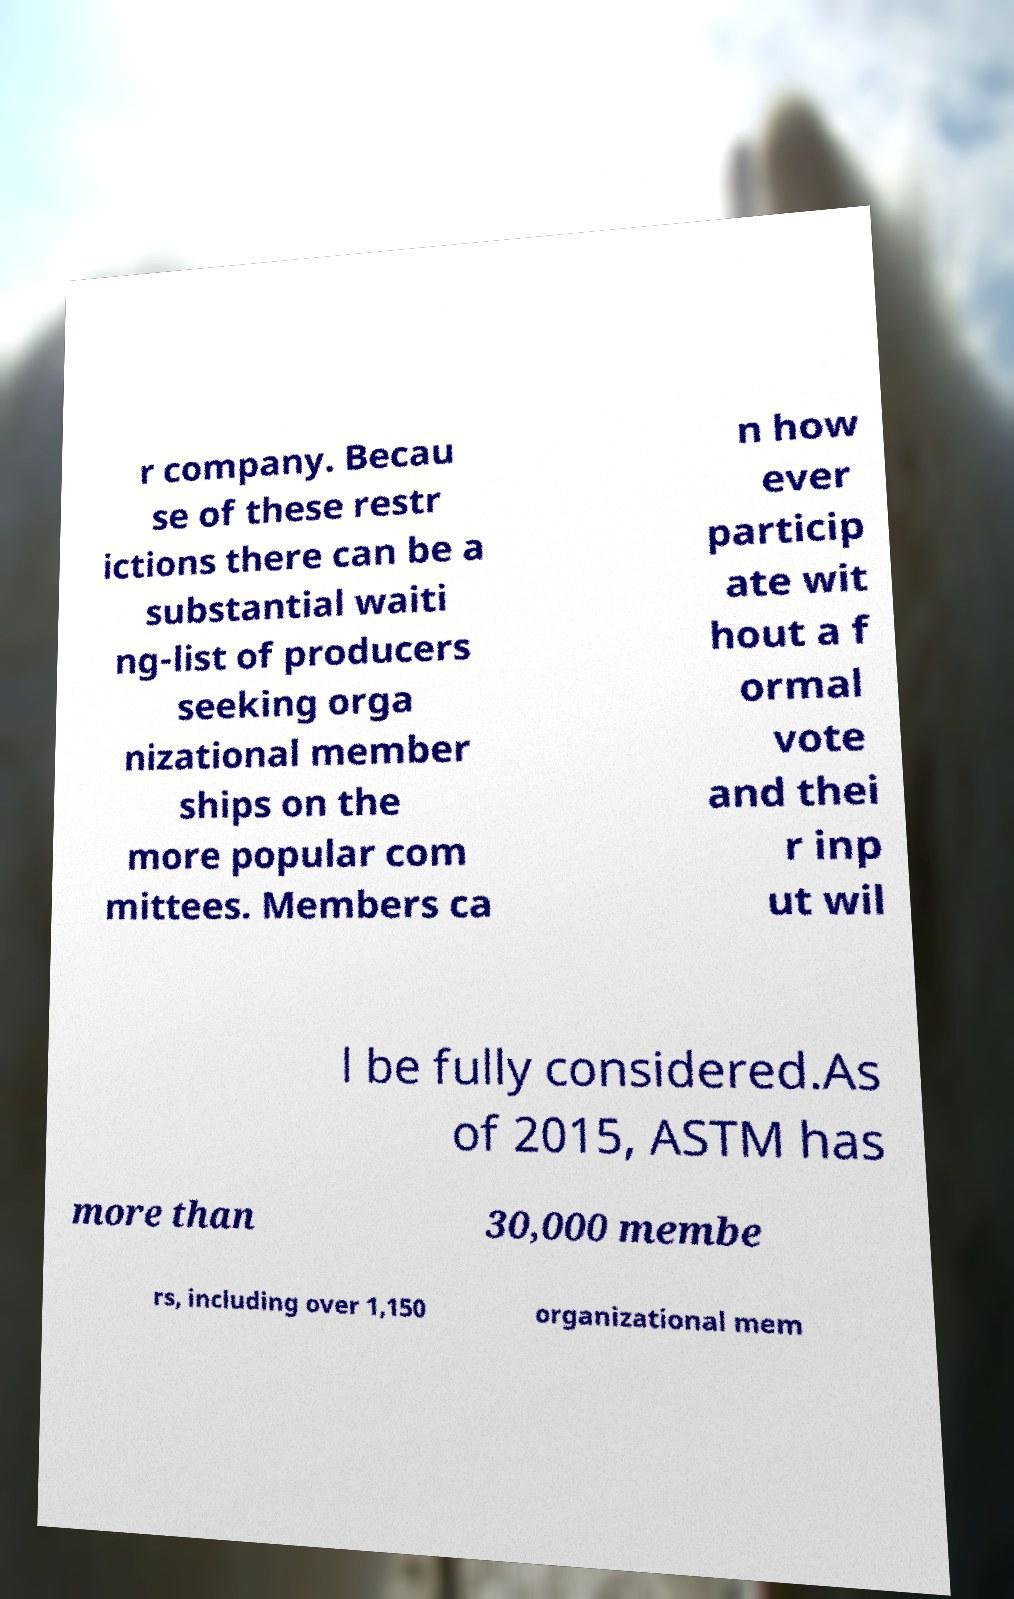Can you read and provide the text displayed in the image?This photo seems to have some interesting text. Can you extract and type it out for me? r company. Becau se of these restr ictions there can be a substantial waiti ng-list of producers seeking orga nizational member ships on the more popular com mittees. Members ca n how ever particip ate wit hout a f ormal vote and thei r inp ut wil l be fully considered.As of 2015, ASTM has more than 30,000 membe rs, including over 1,150 organizational mem 